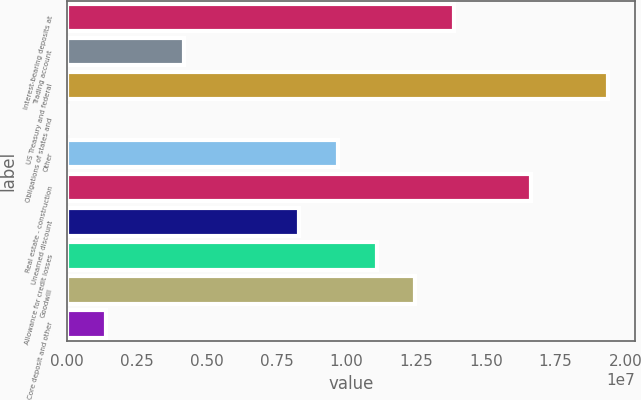<chart> <loc_0><loc_0><loc_500><loc_500><bar_chart><fcel>Interest-bearing deposits at<fcel>Trading account<fcel>US Treasury and federal<fcel>Obligations of states and<fcel>Other<fcel>Real estate - construction<fcel>Unearned discount<fcel>Allowance for credit losses<fcel>Goodwill<fcel>Core deposit and other<nl><fcel>1.38518e+07<fcel>4.17456e+06<fcel>1.93817e+07<fcel>27151<fcel>9.70443e+06<fcel>1.66168e+07<fcel>8.32196e+06<fcel>1.10869e+07<fcel>1.24694e+07<fcel>1.40962e+06<nl></chart> 